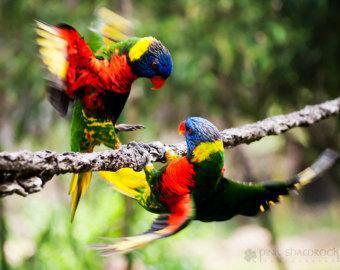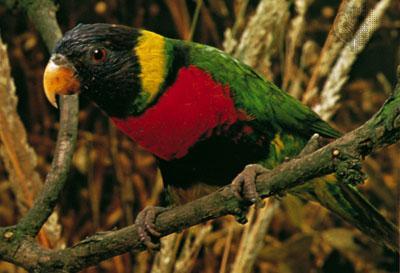The first image is the image on the left, the second image is the image on the right. Given the left and right images, does the statement "Four colorful birds are perched outside." hold true? Answer yes or no. No. The first image is the image on the left, the second image is the image on the right. Evaluate the accuracy of this statement regarding the images: "Left image contains three parrots, and right image contains one left-facing parrot.". Is it true? Answer yes or no. No. 